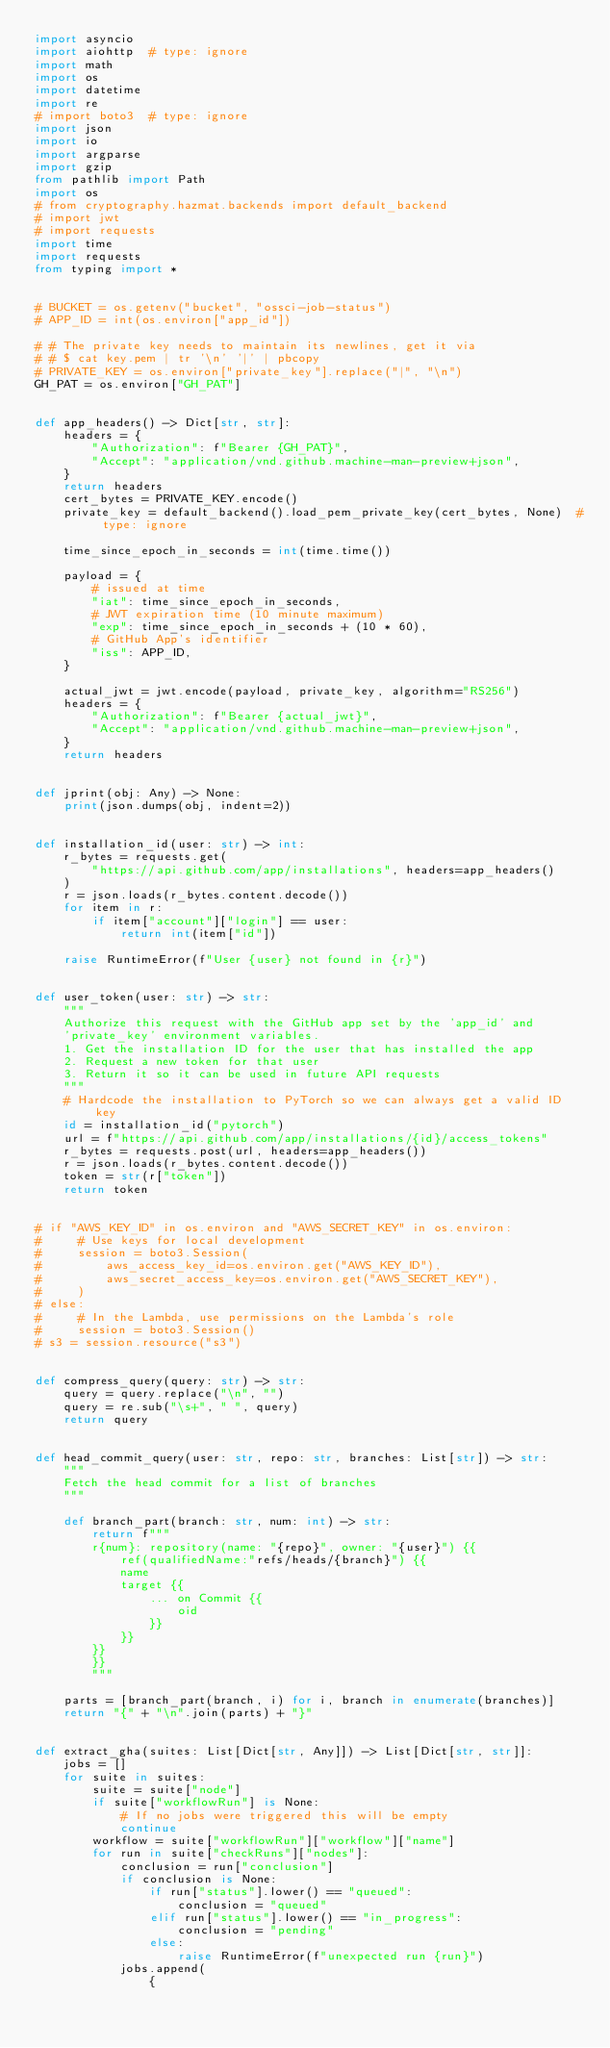Convert code to text. <code><loc_0><loc_0><loc_500><loc_500><_Python_>import asyncio
import aiohttp  # type: ignore
import math
import os
import datetime
import re
# import boto3  # type: ignore
import json
import io
import argparse
import gzip
from pathlib import Path
import os
# from cryptography.hazmat.backends import default_backend
# import jwt
# import requests
import time
import requests
from typing import *


# BUCKET = os.getenv("bucket", "ossci-job-status")
# APP_ID = int(os.environ["app_id"])

# # The private key needs to maintain its newlines, get it via
# # $ cat key.pem | tr '\n' '|' | pbcopy
# PRIVATE_KEY = os.environ["private_key"].replace("|", "\n")
GH_PAT = os.environ["GH_PAT"]


def app_headers() -> Dict[str, str]:
    headers = {
        "Authorization": f"Bearer {GH_PAT}",
        "Accept": "application/vnd.github.machine-man-preview+json",
    }
    return headers
    cert_bytes = PRIVATE_KEY.encode()
    private_key = default_backend().load_pem_private_key(cert_bytes, None)  # type: ignore

    time_since_epoch_in_seconds = int(time.time())

    payload = {
        # issued at time
        "iat": time_since_epoch_in_seconds,
        # JWT expiration time (10 minute maximum)
        "exp": time_since_epoch_in_seconds + (10 * 60),
        # GitHub App's identifier
        "iss": APP_ID,
    }

    actual_jwt = jwt.encode(payload, private_key, algorithm="RS256")
    headers = {
        "Authorization": f"Bearer {actual_jwt}",
        "Accept": "application/vnd.github.machine-man-preview+json",
    }
    return headers


def jprint(obj: Any) -> None:
    print(json.dumps(obj, indent=2))


def installation_id(user: str) -> int:
    r_bytes = requests.get(
        "https://api.github.com/app/installations", headers=app_headers()
    )
    r = json.loads(r_bytes.content.decode())
    for item in r:
        if item["account"]["login"] == user:
            return int(item["id"])

    raise RuntimeError(f"User {user} not found in {r}")


def user_token(user: str) -> str:
    """
    Authorize this request with the GitHub app set by the 'app_id' and
    'private_key' environment variables.
    1. Get the installation ID for the user that has installed the app
    2. Request a new token for that user
    3. Return it so it can be used in future API requests
    """
    # Hardcode the installation to PyTorch so we can always get a valid ID key
    id = installation_id("pytorch")
    url = f"https://api.github.com/app/installations/{id}/access_tokens"
    r_bytes = requests.post(url, headers=app_headers())
    r = json.loads(r_bytes.content.decode())
    token = str(r["token"])
    return token


# if "AWS_KEY_ID" in os.environ and "AWS_SECRET_KEY" in os.environ:
#     # Use keys for local development
#     session = boto3.Session(
#         aws_access_key_id=os.environ.get("AWS_KEY_ID"),
#         aws_secret_access_key=os.environ.get("AWS_SECRET_KEY"),
#     )
# else:
#     # In the Lambda, use permissions on the Lambda's role
#     session = boto3.Session()
# s3 = session.resource("s3")


def compress_query(query: str) -> str:
    query = query.replace("\n", "")
    query = re.sub("\s+", " ", query)
    return query


def head_commit_query(user: str, repo: str, branches: List[str]) -> str:
    """
    Fetch the head commit for a list of branches
    """

    def branch_part(branch: str, num: int) -> str:
        return f"""
        r{num}: repository(name: "{repo}", owner: "{user}") {{
            ref(qualifiedName:"refs/heads/{branch}") {{
            name
            target {{
                ... on Commit {{
                    oid
                }}        
            }}
        }}
        }}
        """

    parts = [branch_part(branch, i) for i, branch in enumerate(branches)]
    return "{" + "\n".join(parts) + "}"


def extract_gha(suites: List[Dict[str, Any]]) -> List[Dict[str, str]]:
    jobs = []
    for suite in suites:
        suite = suite["node"]
        if suite["workflowRun"] is None:
            # If no jobs were triggered this will be empty
            continue
        workflow = suite["workflowRun"]["workflow"]["name"]
        for run in suite["checkRuns"]["nodes"]:
            conclusion = run["conclusion"]
            if conclusion is None:
                if run["status"].lower() == "queued":
                    conclusion = "queued"
                elif run["status"].lower() == "in_progress":
                    conclusion = "pending"
                else:
                    raise RuntimeError(f"unexpected run {run}")
            jobs.append(
                {</code> 